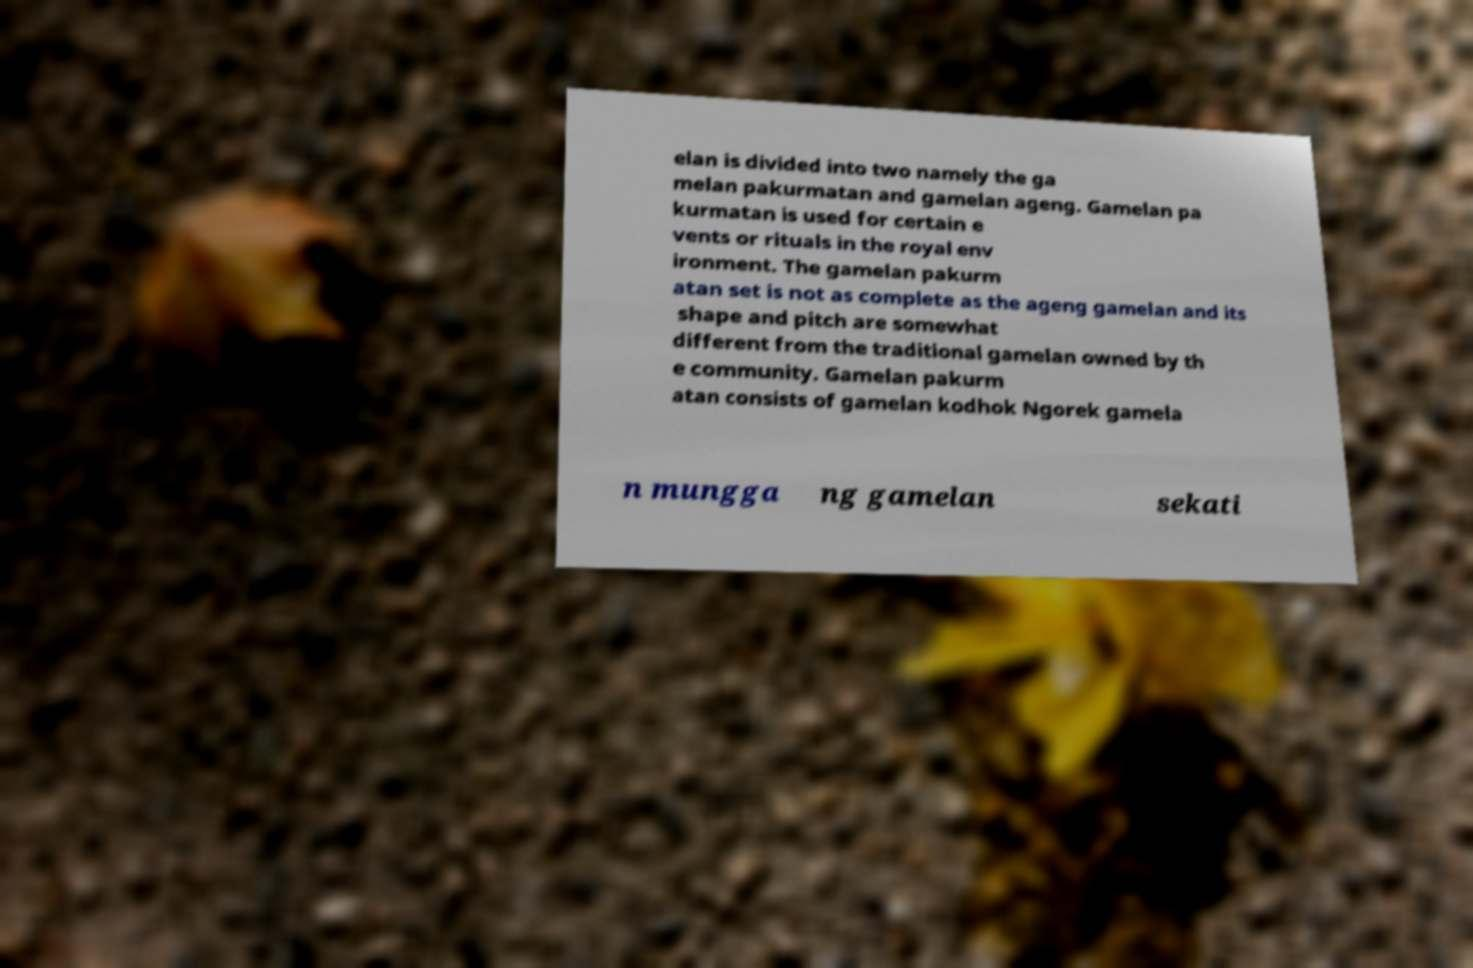Can you read and provide the text displayed in the image?This photo seems to have some interesting text. Can you extract and type it out for me? elan is divided into two namely the ga melan pakurmatan and gamelan ageng. Gamelan pa kurmatan is used for certain e vents or rituals in the royal env ironment. The gamelan pakurm atan set is not as complete as the ageng gamelan and its shape and pitch are somewhat different from the traditional gamelan owned by th e community. Gamelan pakurm atan consists of gamelan kodhok Ngorek gamela n mungga ng gamelan sekati 